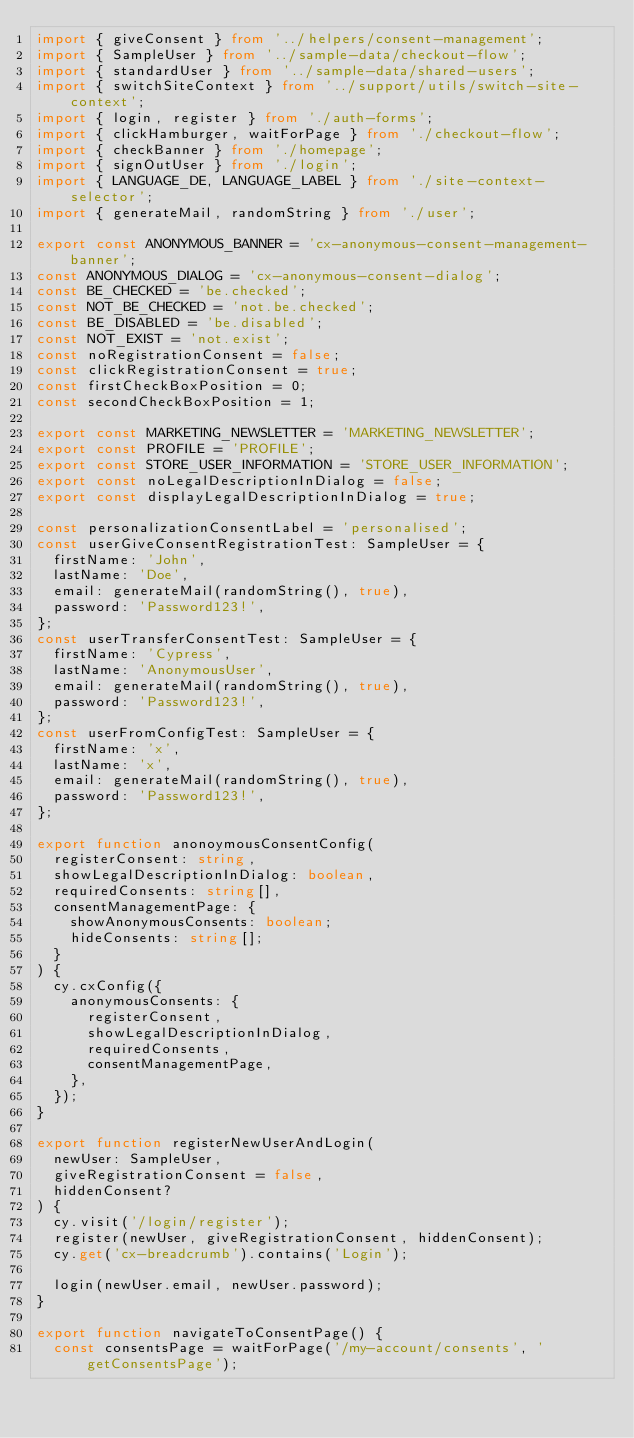Convert code to text. <code><loc_0><loc_0><loc_500><loc_500><_TypeScript_>import { giveConsent } from '../helpers/consent-management';
import { SampleUser } from '../sample-data/checkout-flow';
import { standardUser } from '../sample-data/shared-users';
import { switchSiteContext } from '../support/utils/switch-site-context';
import { login, register } from './auth-forms';
import { clickHamburger, waitForPage } from './checkout-flow';
import { checkBanner } from './homepage';
import { signOutUser } from './login';
import { LANGUAGE_DE, LANGUAGE_LABEL } from './site-context-selector';
import { generateMail, randomString } from './user';

export const ANONYMOUS_BANNER = 'cx-anonymous-consent-management-banner';
const ANONYMOUS_DIALOG = 'cx-anonymous-consent-dialog';
const BE_CHECKED = 'be.checked';
const NOT_BE_CHECKED = 'not.be.checked';
const BE_DISABLED = 'be.disabled';
const NOT_EXIST = 'not.exist';
const noRegistrationConsent = false;
const clickRegistrationConsent = true;
const firstCheckBoxPosition = 0;
const secondCheckBoxPosition = 1;

export const MARKETING_NEWSLETTER = 'MARKETING_NEWSLETTER';
export const PROFILE = 'PROFILE';
export const STORE_USER_INFORMATION = 'STORE_USER_INFORMATION';
export const noLegalDescriptionInDialog = false;
export const displayLegalDescriptionInDialog = true;

const personalizationConsentLabel = 'personalised';
const userGiveConsentRegistrationTest: SampleUser = {
  firstName: 'John',
  lastName: 'Doe',
  email: generateMail(randomString(), true),
  password: 'Password123!',
};
const userTransferConsentTest: SampleUser = {
  firstName: 'Cypress',
  lastName: 'AnonymousUser',
  email: generateMail(randomString(), true),
  password: 'Password123!',
};
const userFromConfigTest: SampleUser = {
  firstName: 'x',
  lastName: 'x',
  email: generateMail(randomString(), true),
  password: 'Password123!',
};

export function anonoymousConsentConfig(
  registerConsent: string,
  showLegalDescriptionInDialog: boolean,
  requiredConsents: string[],
  consentManagementPage: {
    showAnonymousConsents: boolean;
    hideConsents: string[];
  }
) {
  cy.cxConfig({
    anonymousConsents: {
      registerConsent,
      showLegalDescriptionInDialog,
      requiredConsents,
      consentManagementPage,
    },
  });
}

export function registerNewUserAndLogin(
  newUser: SampleUser,
  giveRegistrationConsent = false,
  hiddenConsent?
) {
  cy.visit('/login/register');
  register(newUser, giveRegistrationConsent, hiddenConsent);
  cy.get('cx-breadcrumb').contains('Login');

  login(newUser.email, newUser.password);
}

export function navigateToConsentPage() {
  const consentsPage = waitForPage('/my-account/consents', 'getConsentsPage');</code> 